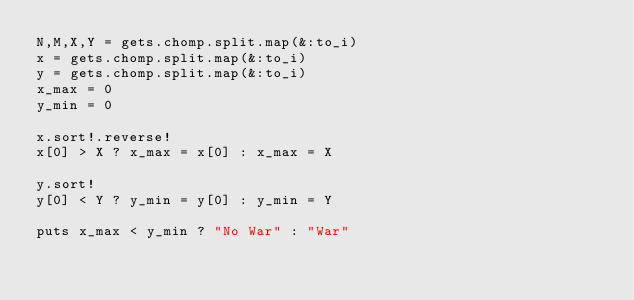<code> <loc_0><loc_0><loc_500><loc_500><_Ruby_>N,M,X,Y = gets.chomp.split.map(&:to_i)
x = gets.chomp.split.map(&:to_i)
y = gets.chomp.split.map(&:to_i)
x_max = 0
y_min = 0

x.sort!.reverse!
x[0] > X ? x_max = x[0] : x_max = X

y.sort!
y[0] < Y ? y_min = y[0] : y_min = Y

puts x_max < y_min ? "No War" : "War"</code> 